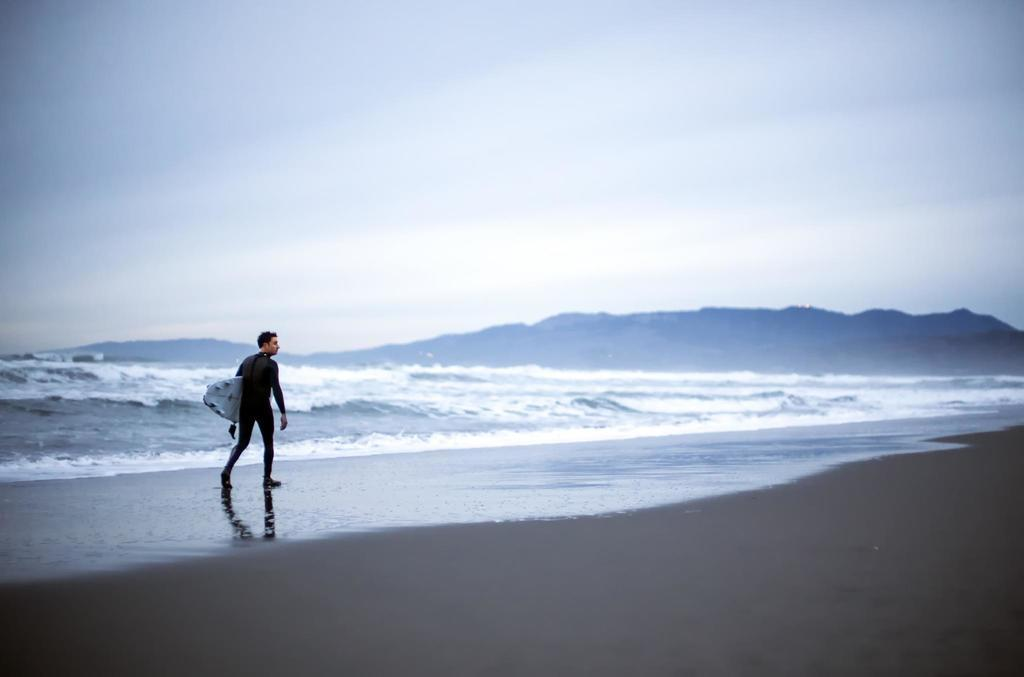What is the main subject of the image? There is a person in the image. What is the person doing in the image? The person is standing on the ground and holding a surfboard. What can be seen in the background of the image? There is water, mountains, and the sky visible in the background. What type of disease is the person suffering from in the image? There is no indication of any disease in the image; the person is simply standing on the ground and holding a surfboard. 